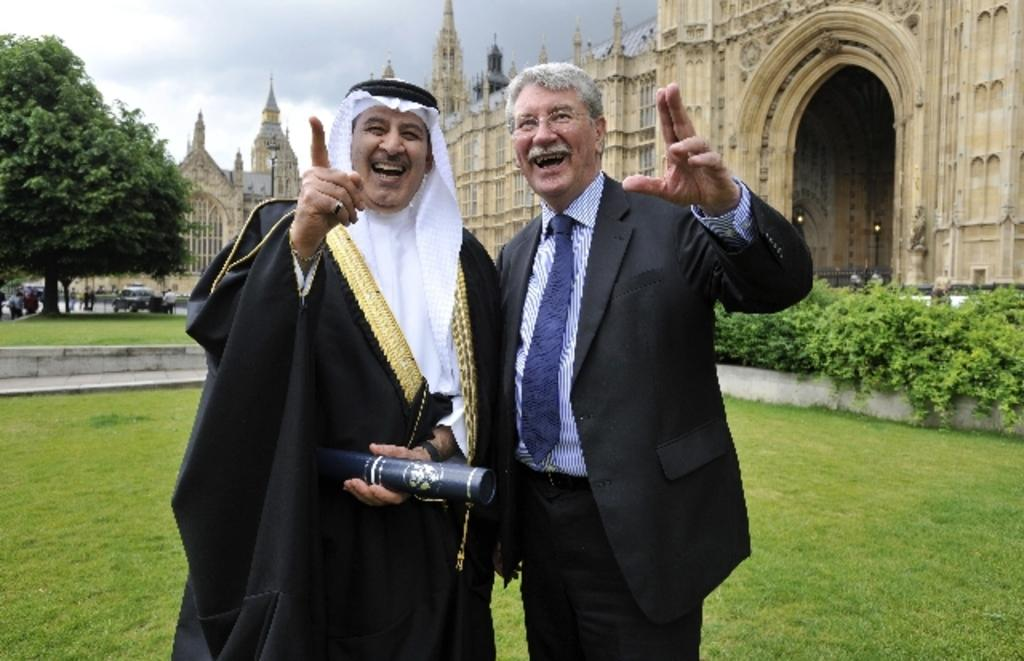How many people are present in the image? There are two people standing in the image. What type of natural environment is visible in the image? There is grass visible in the image. What type of structures can be seen in the image? There are buildings in the image. What other types of vegetation are present in the image? There are plants and trees in the image. What is visible in the background of the image? The sky is visible in the image. How many mice are playing volleyball in the image? There are no mice or volleyball present in the image. What things are being used to play the game of volleyball in the image? There is no game of volleyball present in the image, so no things are being used to play it. 